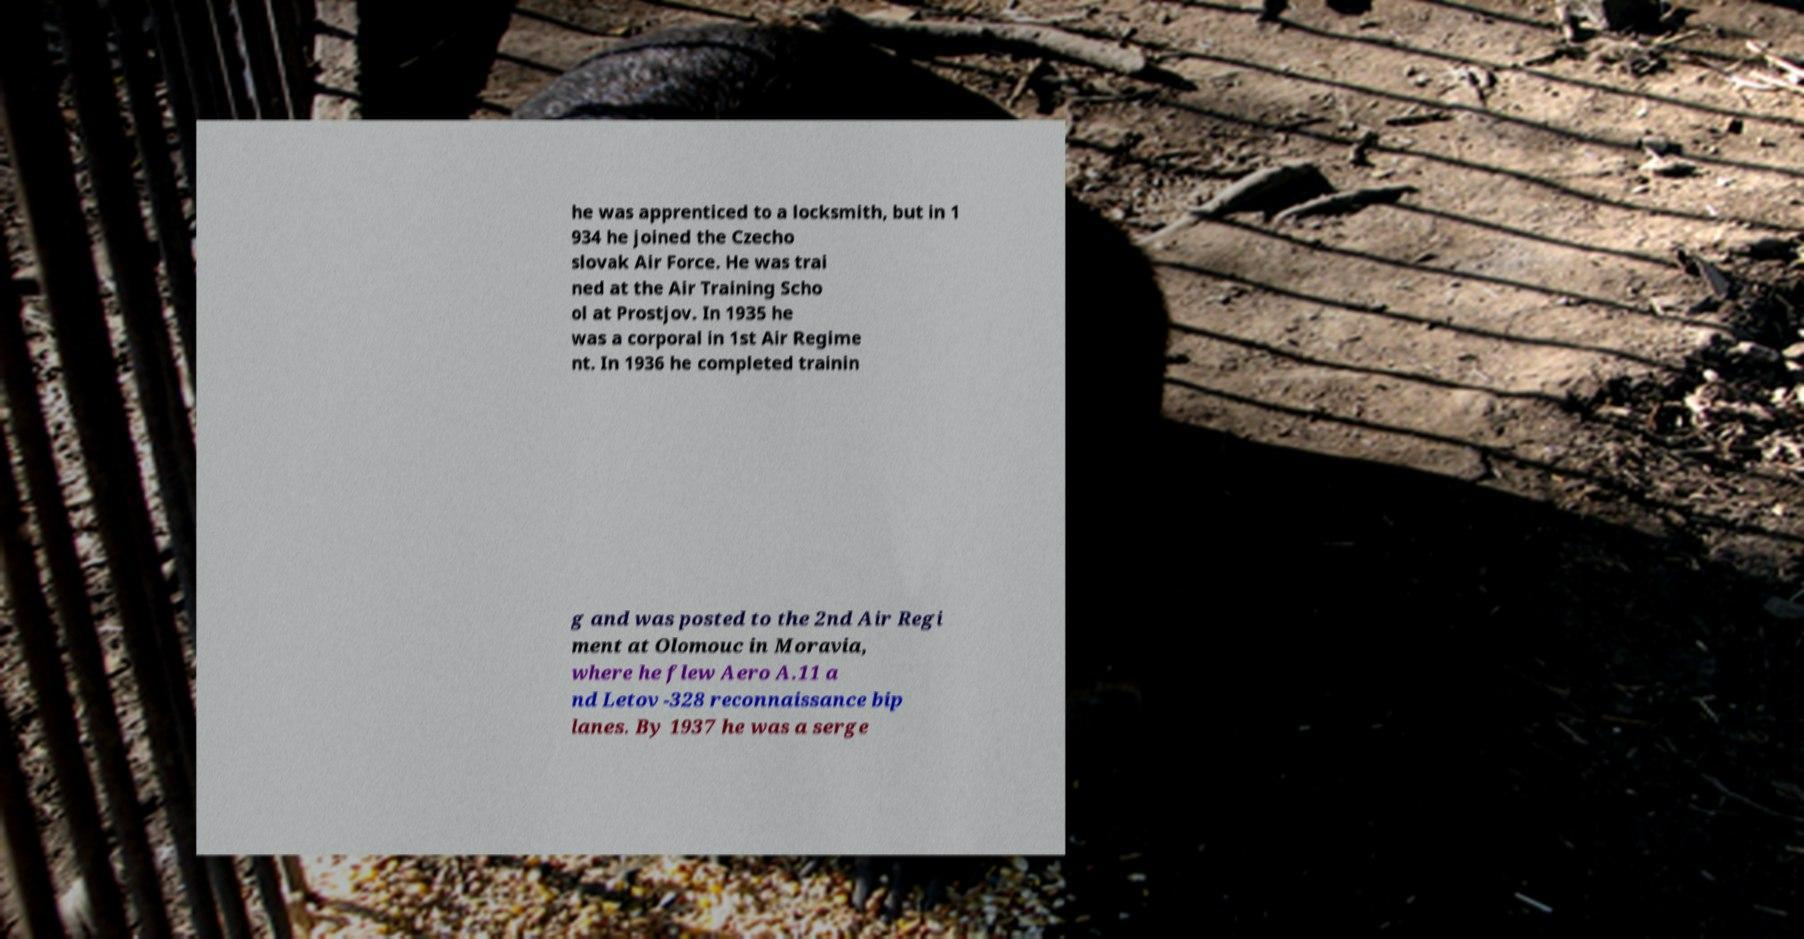Please read and relay the text visible in this image. What does it say? he was apprenticed to a locksmith, but in 1 934 he joined the Czecho slovak Air Force. He was trai ned at the Air Training Scho ol at Prostjov. In 1935 he was a corporal in 1st Air Regime nt. In 1936 he completed trainin g and was posted to the 2nd Air Regi ment at Olomouc in Moravia, where he flew Aero A.11 a nd Letov -328 reconnaissance bip lanes. By 1937 he was a serge 